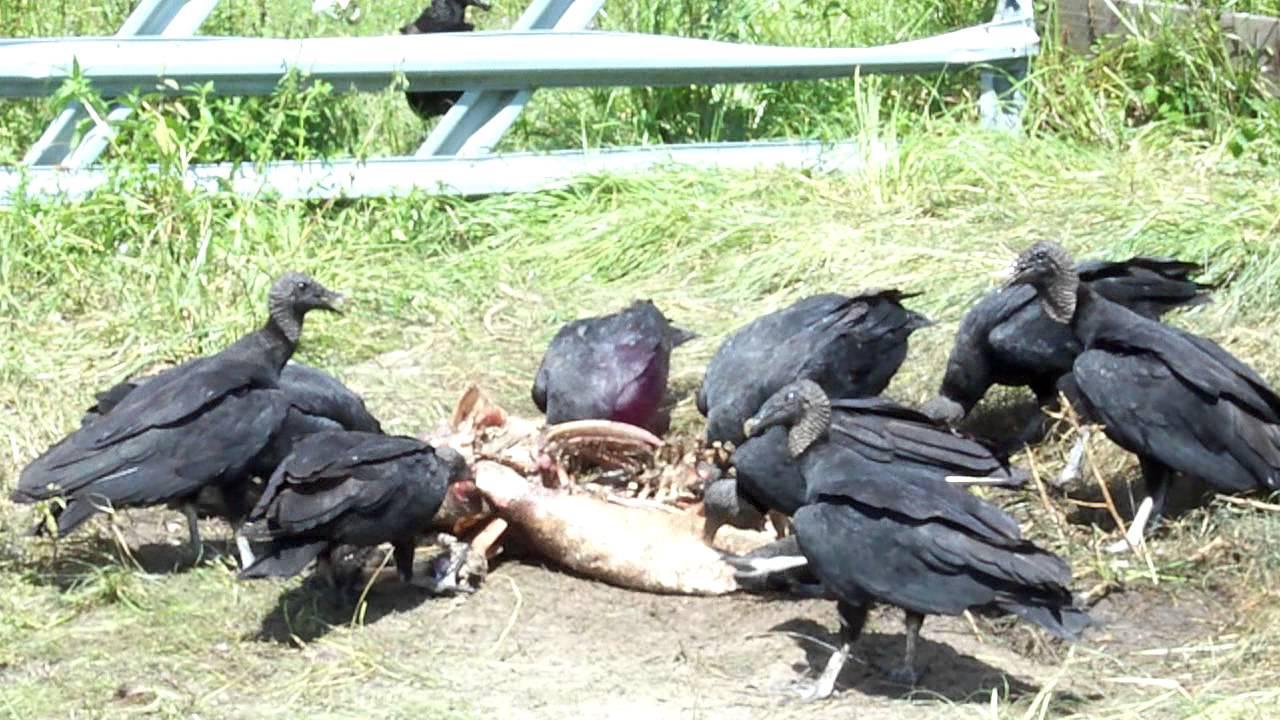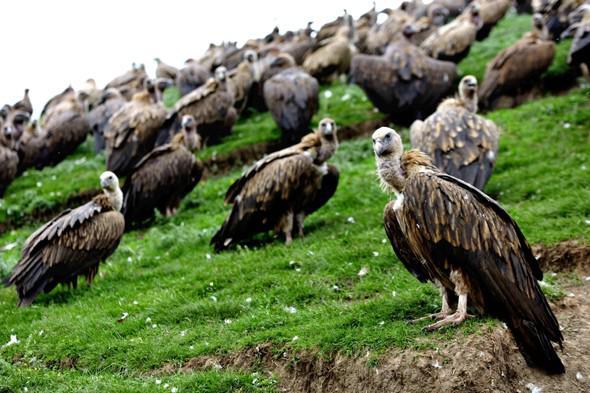The first image is the image on the left, the second image is the image on the right. Given the left and right images, does the statement "There is a human skeleton next to a group of vultures in one of the images." hold true? Answer yes or no. No. The first image is the image on the left, the second image is the image on the right. For the images shown, is this caption "In every image, the vultures are eating." true? Answer yes or no. No. 